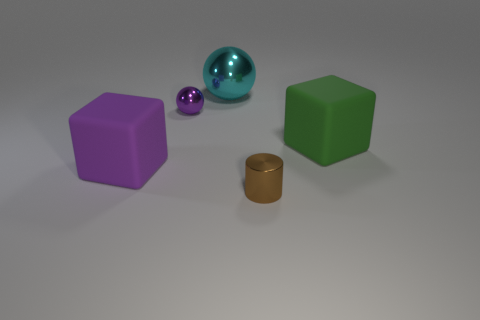Add 1 green spheres. How many objects exist? 6 Subtract all cylinders. How many objects are left? 4 Subtract all purple rubber cylinders. Subtract all purple metallic things. How many objects are left? 4 Add 4 big purple matte things. How many big purple matte things are left? 5 Add 1 large green cylinders. How many large green cylinders exist? 1 Subtract 1 purple blocks. How many objects are left? 4 